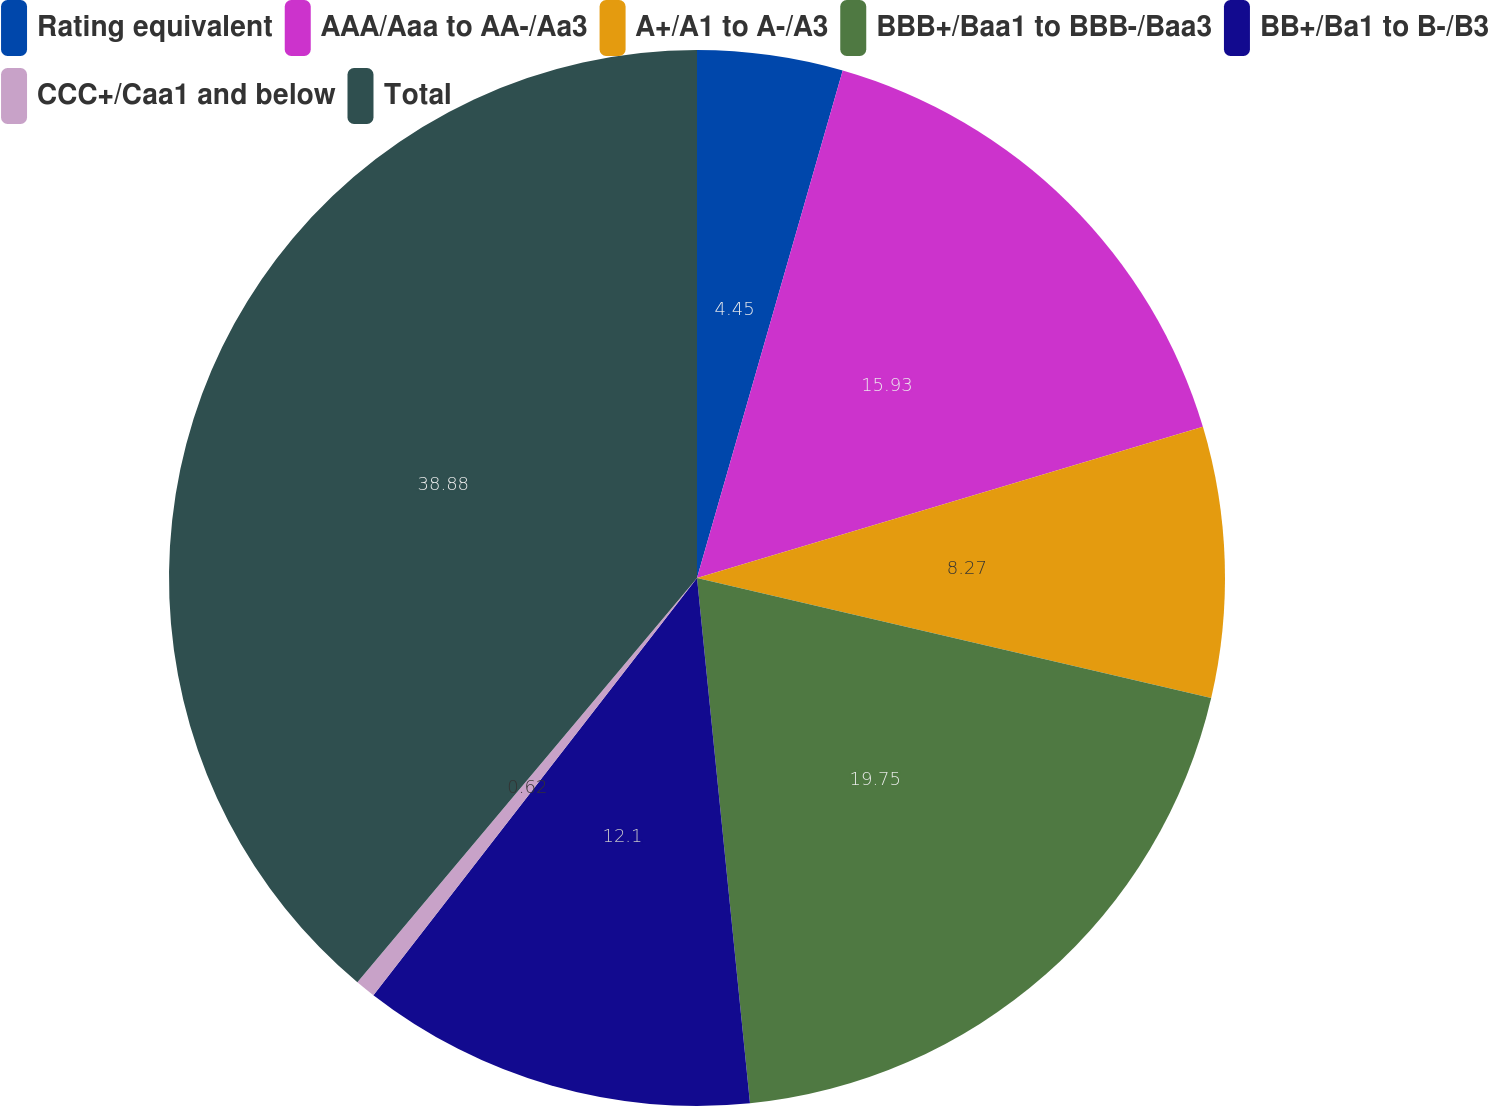Convert chart to OTSL. <chart><loc_0><loc_0><loc_500><loc_500><pie_chart><fcel>Rating equivalent<fcel>AAA/Aaa to AA-/Aa3<fcel>A+/A1 to A-/A3<fcel>BBB+/Baa1 to BBB-/Baa3<fcel>BB+/Ba1 to B-/B3<fcel>CCC+/Caa1 and below<fcel>Total<nl><fcel>4.45%<fcel>15.93%<fcel>8.27%<fcel>19.75%<fcel>12.1%<fcel>0.62%<fcel>38.88%<nl></chart> 